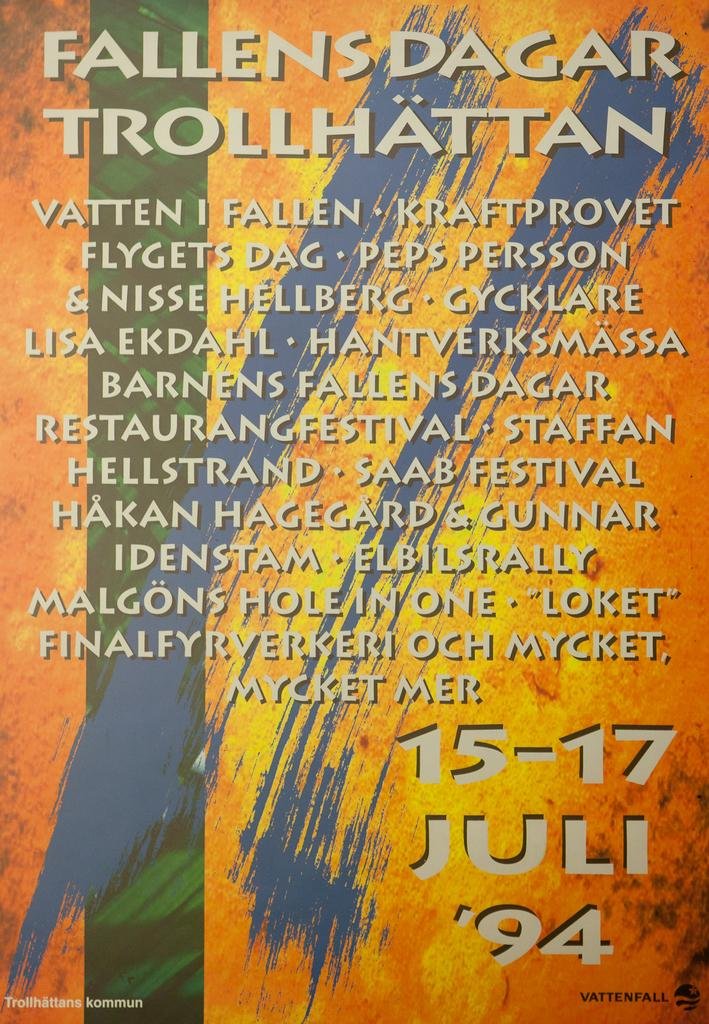Provide a one-sentence caption for the provided image. A poster for a 1994 event called Fallens Dagar Trollhattan. 